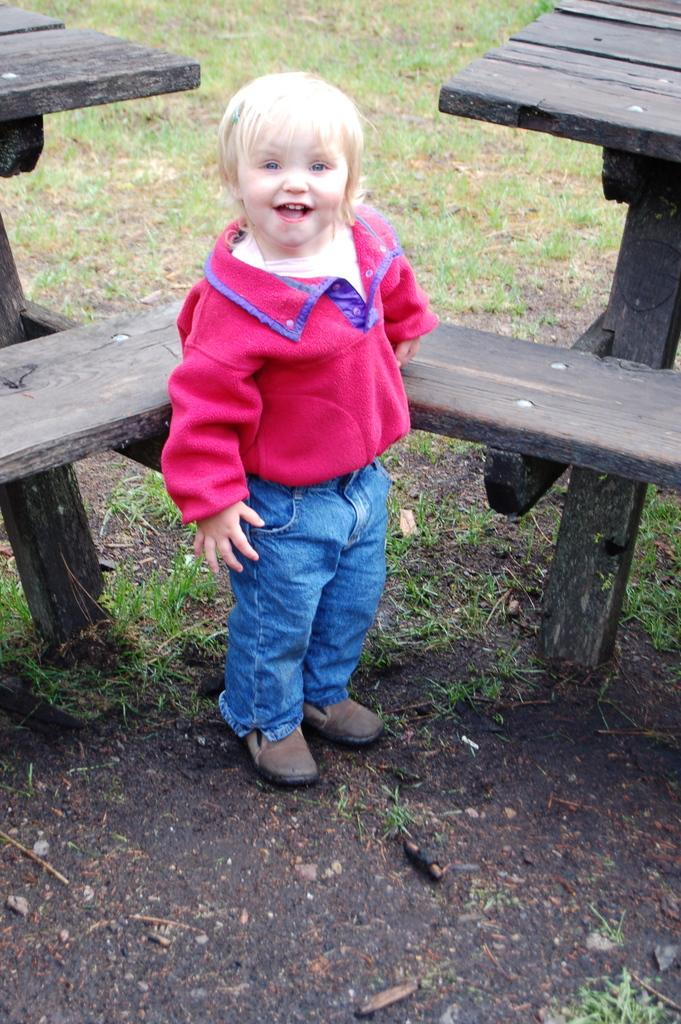What is the main subject of the image? The main subject of the image is a small child. Can you describe the child's clothing? The child is wearing a red dress and black jeans. What can be seen in the background of the image? There are two tables and grass in the background of the image. What type of expert is giving a speech at the airport in the image? There is no expert or airport present in the image; it features a small child wearing a red dress and black jeans. 